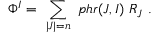Convert formula to latex. <formula><loc_0><loc_0><loc_500><loc_500>\Phi ^ { I } = \ \sum _ { | J | = n } \ p h r ( J , I ) \ R _ { J } \ .</formula> 